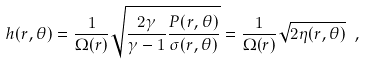<formula> <loc_0><loc_0><loc_500><loc_500>h ( r , \theta ) = \frac { 1 } { \Omega ( r ) } \sqrt { \frac { 2 \gamma } { \gamma - 1 } \frac { P ( r , \theta ) } { \sigma ( r , \theta ) } } = \frac { 1 } { \Omega ( r ) } \sqrt { 2 \eta ( r , \theta ) } \ ,</formula> 